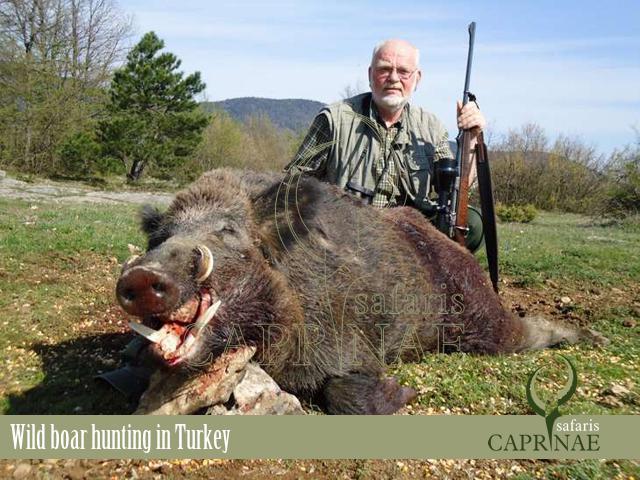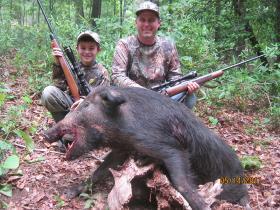The first image is the image on the left, the second image is the image on the right. Assess this claim about the two images: "Two hunters are posing with their kill in the image on the right.". Correct or not? Answer yes or no. Yes. The first image is the image on the left, the second image is the image on the right. Assess this claim about the two images: "In total, two dead hogs are shown.". Correct or not? Answer yes or no. Yes. 